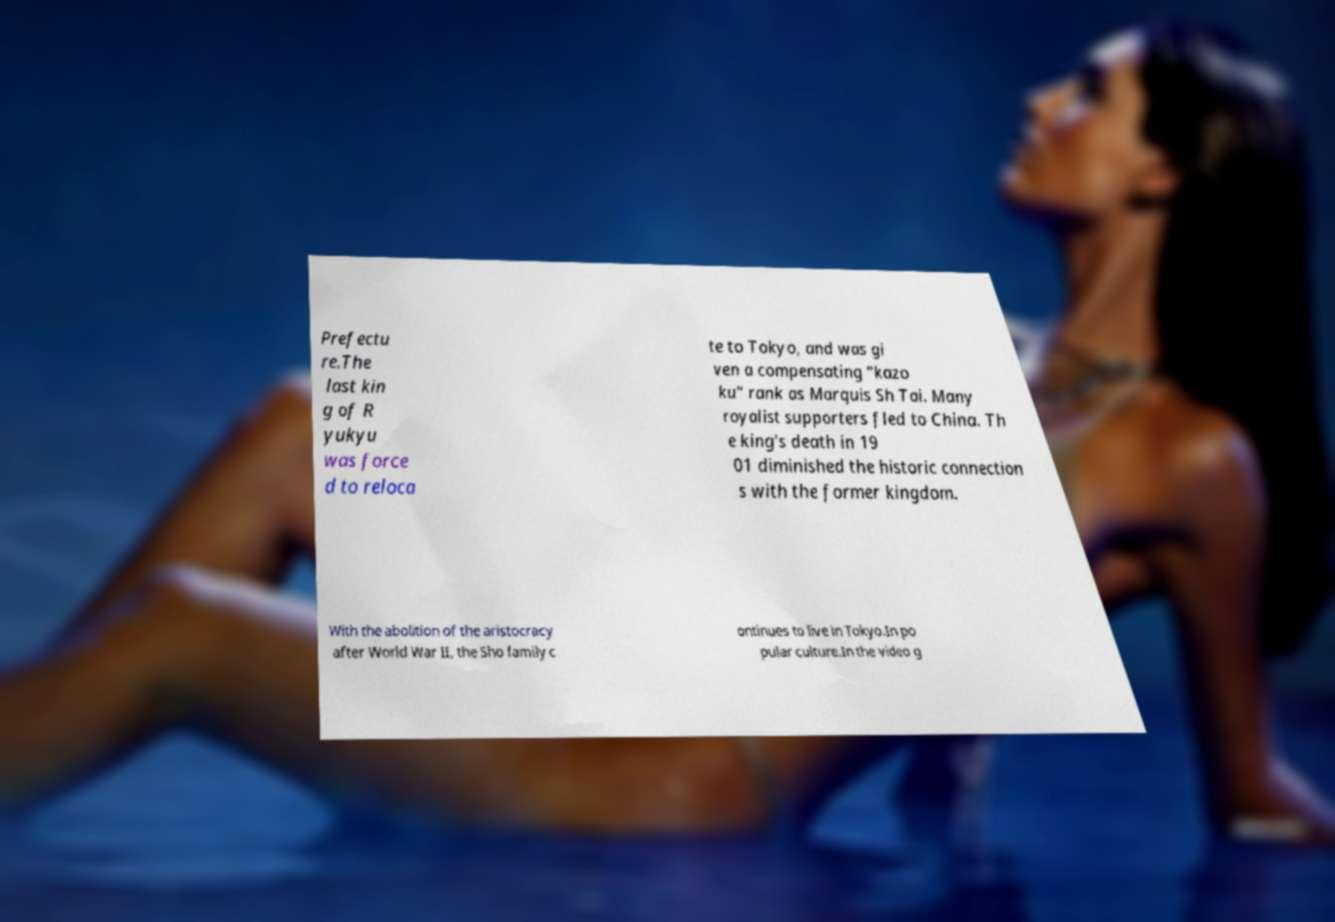Could you assist in decoding the text presented in this image and type it out clearly? Prefectu re.The last kin g of R yukyu was force d to reloca te to Tokyo, and was gi ven a compensating "kazo ku" rank as Marquis Sh Tai. Many royalist supporters fled to China. Th e king's death in 19 01 diminished the historic connection s with the former kingdom. With the abolition of the aristocracy after World War II, the Sho family c ontinues to live in Tokyo.In po pular culture.In the video g 